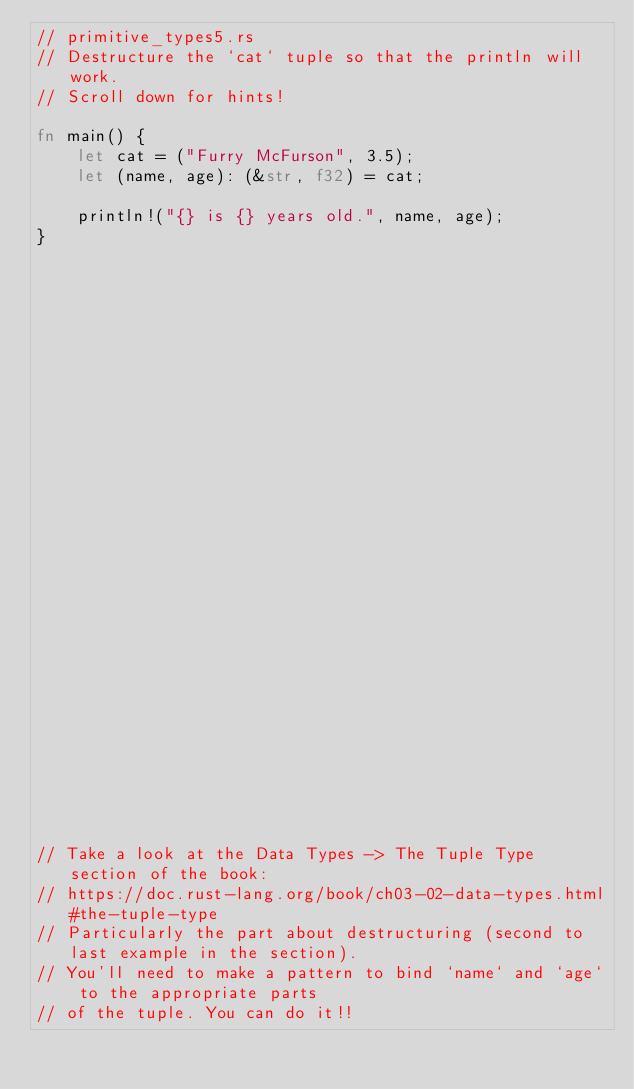Convert code to text. <code><loc_0><loc_0><loc_500><loc_500><_Rust_>// primitive_types5.rs
// Destructure the `cat` tuple so that the println will work.
// Scroll down for hints!

fn main() {
    let cat = ("Furry McFurson", 3.5);
    let (name, age): (&str, f32) = cat;

    println!("{} is {} years old.", name, age);
}






























// Take a look at the Data Types -> The Tuple Type section of the book:
// https://doc.rust-lang.org/book/ch03-02-data-types.html#the-tuple-type
// Particularly the part about destructuring (second to last example in the section).
// You'll need to make a pattern to bind `name` and `age` to the appropriate parts
// of the tuple. You can do it!!
</code> 